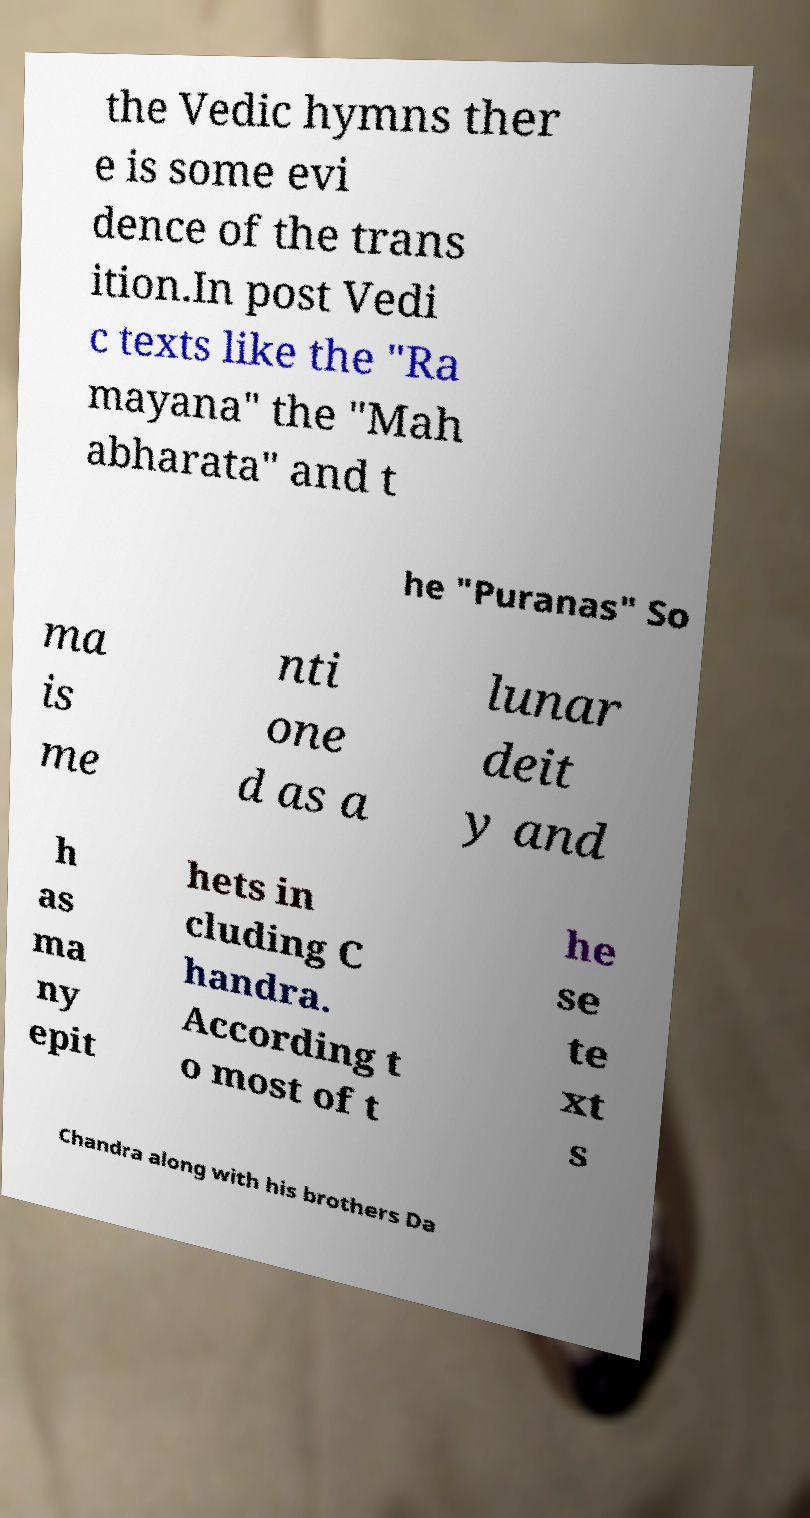What messages or text are displayed in this image? I need them in a readable, typed format. the Vedic hymns ther e is some evi dence of the trans ition.In post Vedi c texts like the "Ra mayana" the "Mah abharata" and t he "Puranas" So ma is me nti one d as a lunar deit y and h as ma ny epit hets in cluding C handra. According t o most of t he se te xt s Chandra along with his brothers Da 